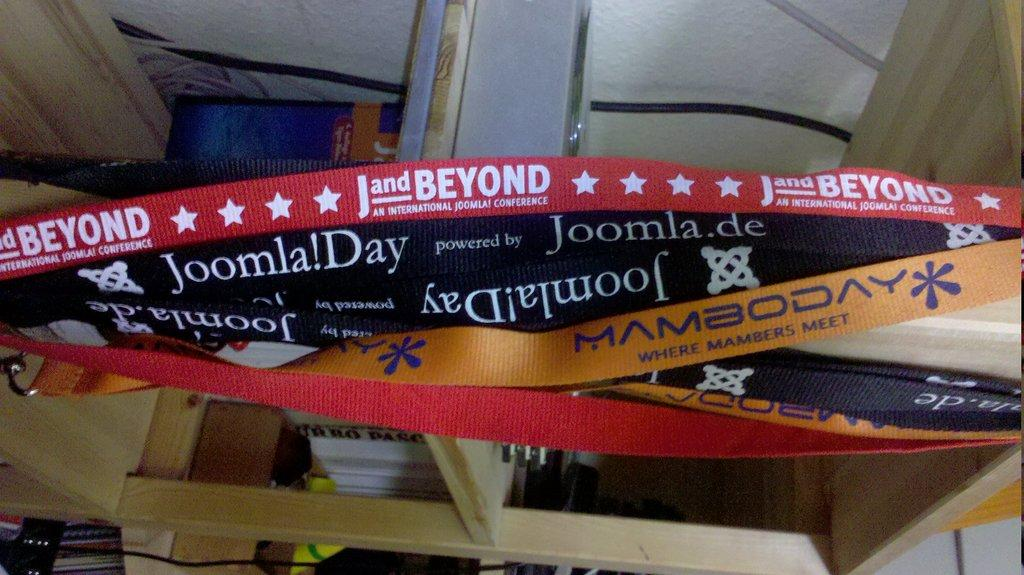<image>
Create a compact narrative representing the image presented. A cluster of lanyards is hanging from a shelf including one that says Joomla!Day. 